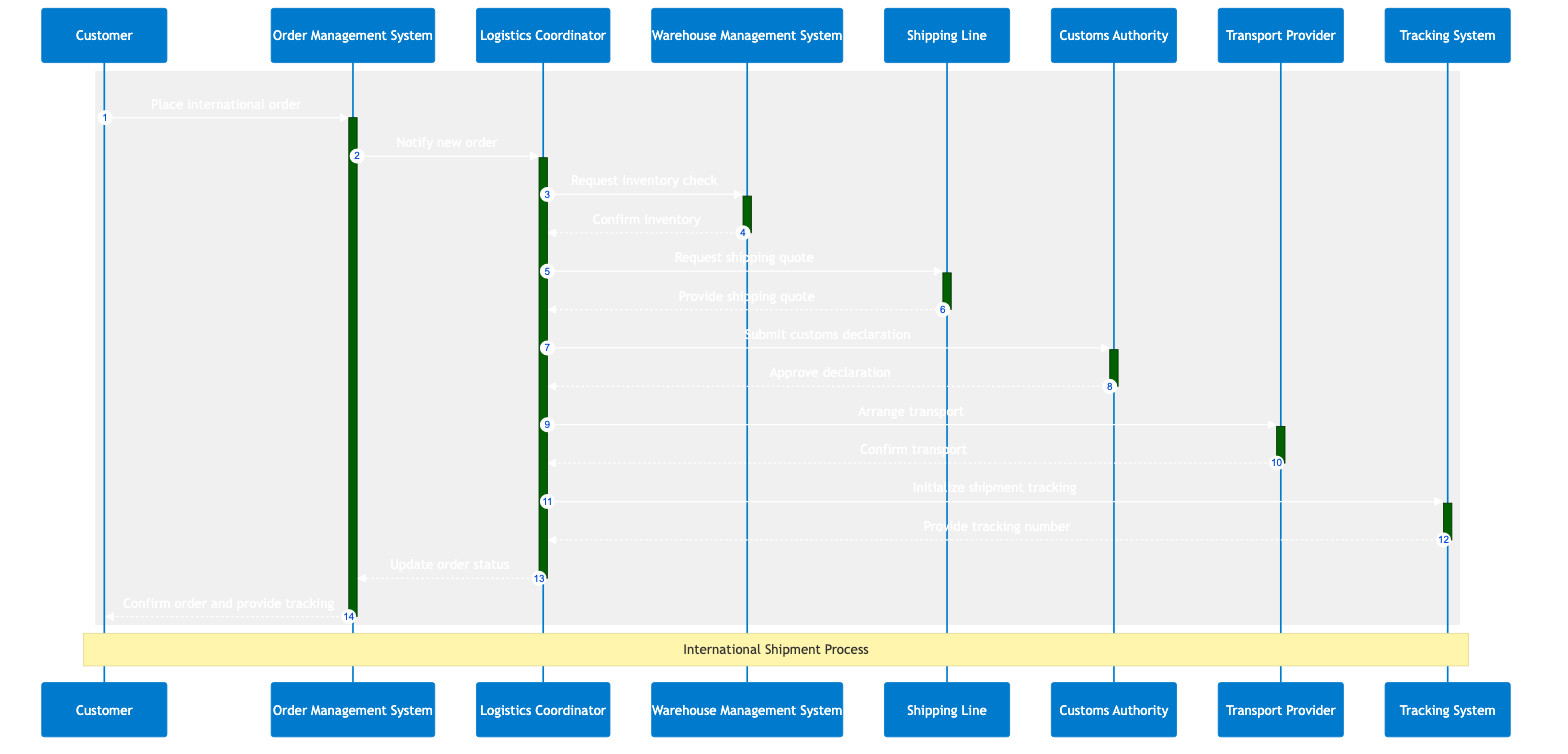What is the first action in the order processing workflow? The first action is when the Customer places an international order. This is indicated by the arrow originating from the Customer pointing to the Order Management System.
Answer: Place international order How many actors are involved in the order processing workflow? There are a total of six actors involved in the workflow: Customer, Logistics Coordinator, Shipping Line, Customs Authority, Transport Provider, and Tracking System. Each of these roles is represented in the diagram.
Answer: Six What does the Logistics Coordinator do after receiving the shipping quote? After receiving the shipping quote from the Shipping Line, the Logistics Coordinator arranges transport by communicating with the Transport Provider. This is captured in the sequence after the quote interaction.
Answer: Arrange transport Which system confirms the inventory to the Logistics Coordinator? The Warehouse Management System confirms the inventory out to the Logistics Coordinator. In the sequence, the arrow indicates that the WMS sends a response back to the LC.
Answer: Confirm inventory What is initialized by the Logistics Coordinator after arranging transportation? The Logistics Coordinator initializes shipment tracking right after arranging transportation, as reflected in the subsequent step of the sequence diagram.
Answer: Initialize shipment tracking Describe the relationship between the Logistics Coordinator and the Customs Authority in this workflow. The Logistics Coordinator submits a customs declaration to the Customs Authority, which then approves the declaration. This indicates a direct interaction where the LC seeks approval from the CA for the customs process.
Answer: Submit customs declaration How does the Order Management System respond after the order status is updated? The Order Management System confirms the order and provides tracking information to the Customer after updating the order status, as shown at the end of the sequence.
Answer: Confirm order and provide tracking What information does the Tracking System provide? The Tracking System provides a tracking number to the Logistics Coordinator after being initialized, which is a critical aspect of shipment tracking in this workflow.
Answer: Provide tracking number How many steps involve feedback from a system to the Logistics Coordinator? There are four interactions where systems provide feedback or confirmations to the Logistics Coordinator: confirming inventory from WMS, providing a shipping quote from SL, approving customs declaration from CA, and providing the tracking number from TS. Each is a pivotal part of the workflow process.
Answer: Four 